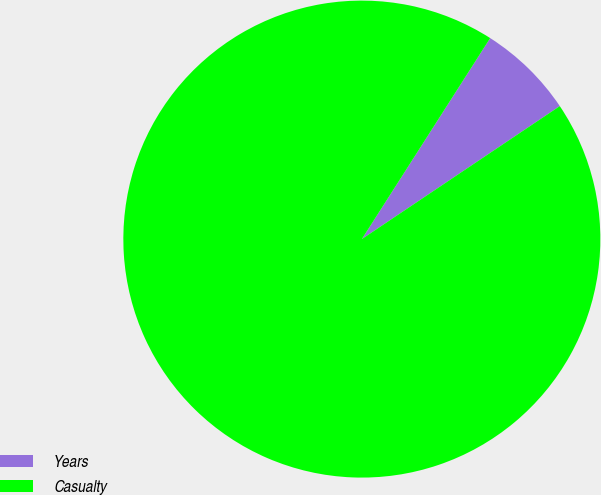Convert chart. <chart><loc_0><loc_0><loc_500><loc_500><pie_chart><fcel>Years<fcel>Casualty<nl><fcel>6.54%<fcel>93.46%<nl></chart> 